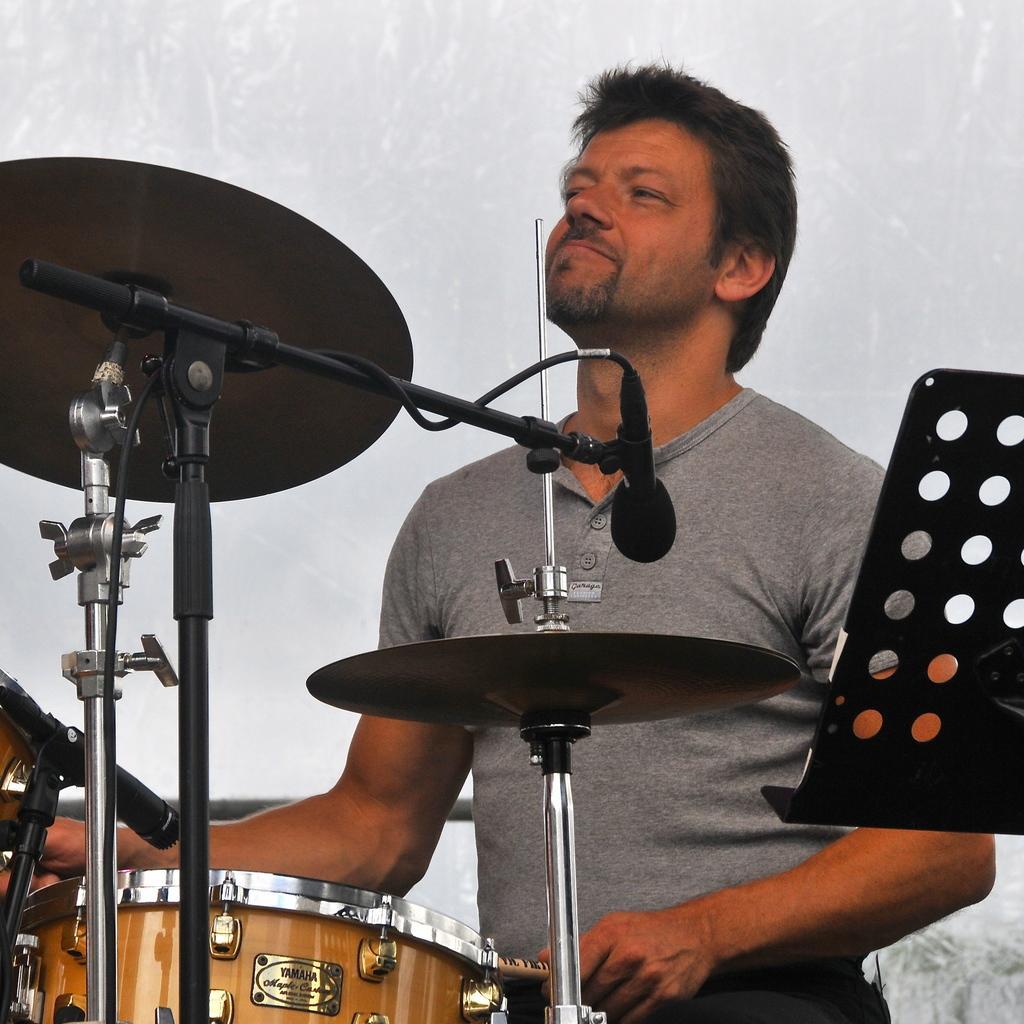Describe this image in one or two sentences. In this image I can see the person wearing the dress and playing the drum set. And there is an ash color background. 